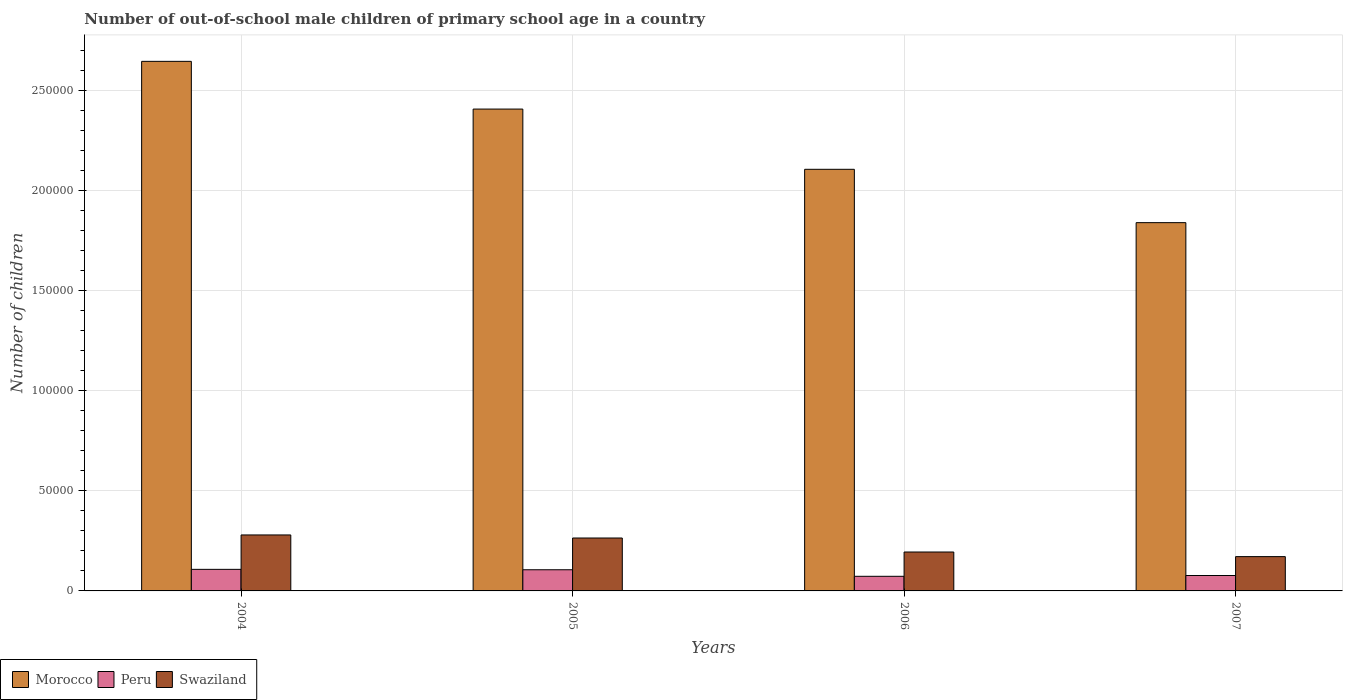How many groups of bars are there?
Give a very brief answer. 4. How many bars are there on the 3rd tick from the right?
Your answer should be very brief. 3. What is the number of out-of-school male children in Morocco in 2007?
Keep it short and to the point. 1.84e+05. Across all years, what is the maximum number of out-of-school male children in Swaziland?
Your answer should be compact. 2.79e+04. Across all years, what is the minimum number of out-of-school male children in Morocco?
Make the answer very short. 1.84e+05. In which year was the number of out-of-school male children in Peru minimum?
Your response must be concise. 2006. What is the total number of out-of-school male children in Peru in the graph?
Your response must be concise. 3.63e+04. What is the difference between the number of out-of-school male children in Swaziland in 2004 and that in 2006?
Your answer should be very brief. 8516. What is the difference between the number of out-of-school male children in Swaziland in 2007 and the number of out-of-school male children in Peru in 2006?
Provide a short and direct response. 9829. What is the average number of out-of-school male children in Swaziland per year?
Give a very brief answer. 2.27e+04. In the year 2005, what is the difference between the number of out-of-school male children in Swaziland and number of out-of-school male children in Peru?
Your answer should be very brief. 1.58e+04. In how many years, is the number of out-of-school male children in Morocco greater than 30000?
Offer a terse response. 4. What is the ratio of the number of out-of-school male children in Peru in 2004 to that in 2006?
Make the answer very short. 1.48. Is the number of out-of-school male children in Swaziland in 2004 less than that in 2007?
Your response must be concise. No. Is the difference between the number of out-of-school male children in Swaziland in 2004 and 2006 greater than the difference between the number of out-of-school male children in Peru in 2004 and 2006?
Your answer should be compact. Yes. What is the difference between the highest and the second highest number of out-of-school male children in Swaziland?
Make the answer very short. 1529. What is the difference between the highest and the lowest number of out-of-school male children in Swaziland?
Offer a terse response. 1.08e+04. Is the sum of the number of out-of-school male children in Swaziland in 2006 and 2007 greater than the maximum number of out-of-school male children in Peru across all years?
Provide a short and direct response. Yes. What does the 1st bar from the right in 2006 represents?
Provide a short and direct response. Swaziland. Is it the case that in every year, the sum of the number of out-of-school male children in Peru and number of out-of-school male children in Morocco is greater than the number of out-of-school male children in Swaziland?
Offer a very short reply. Yes. How many years are there in the graph?
Ensure brevity in your answer.  4. Are the values on the major ticks of Y-axis written in scientific E-notation?
Offer a very short reply. No. Does the graph contain any zero values?
Ensure brevity in your answer.  No. Does the graph contain grids?
Your answer should be compact. Yes. Where does the legend appear in the graph?
Your response must be concise. Bottom left. What is the title of the graph?
Offer a very short reply. Number of out-of-school male children of primary school age in a country. Does "Maldives" appear as one of the legend labels in the graph?
Provide a short and direct response. No. What is the label or title of the Y-axis?
Your answer should be compact. Number of children. What is the Number of children in Morocco in 2004?
Keep it short and to the point. 2.64e+05. What is the Number of children of Peru in 2004?
Offer a terse response. 1.08e+04. What is the Number of children of Swaziland in 2004?
Your answer should be compact. 2.79e+04. What is the Number of children in Morocco in 2005?
Make the answer very short. 2.41e+05. What is the Number of children of Peru in 2005?
Ensure brevity in your answer.  1.06e+04. What is the Number of children of Swaziland in 2005?
Your response must be concise. 2.64e+04. What is the Number of children of Morocco in 2006?
Provide a succinct answer. 2.10e+05. What is the Number of children in Peru in 2006?
Make the answer very short. 7293. What is the Number of children in Swaziland in 2006?
Your response must be concise. 1.94e+04. What is the Number of children of Morocco in 2007?
Your answer should be compact. 1.84e+05. What is the Number of children in Peru in 2007?
Give a very brief answer. 7691. What is the Number of children in Swaziland in 2007?
Offer a very short reply. 1.71e+04. Across all years, what is the maximum Number of children in Morocco?
Give a very brief answer. 2.64e+05. Across all years, what is the maximum Number of children in Peru?
Give a very brief answer. 1.08e+04. Across all years, what is the maximum Number of children in Swaziland?
Your answer should be compact. 2.79e+04. Across all years, what is the minimum Number of children in Morocco?
Offer a very short reply. 1.84e+05. Across all years, what is the minimum Number of children in Peru?
Offer a very short reply. 7293. Across all years, what is the minimum Number of children in Swaziland?
Provide a succinct answer. 1.71e+04. What is the total Number of children of Morocco in the graph?
Provide a succinct answer. 8.99e+05. What is the total Number of children in Peru in the graph?
Keep it short and to the point. 3.63e+04. What is the total Number of children in Swaziland in the graph?
Provide a succinct answer. 9.09e+04. What is the difference between the Number of children of Morocco in 2004 and that in 2005?
Keep it short and to the point. 2.38e+04. What is the difference between the Number of children in Peru in 2004 and that in 2005?
Offer a very short reply. 203. What is the difference between the Number of children of Swaziland in 2004 and that in 2005?
Keep it short and to the point. 1529. What is the difference between the Number of children in Morocco in 2004 and that in 2006?
Offer a very short reply. 5.39e+04. What is the difference between the Number of children in Peru in 2004 and that in 2006?
Ensure brevity in your answer.  3475. What is the difference between the Number of children of Swaziland in 2004 and that in 2006?
Offer a terse response. 8516. What is the difference between the Number of children of Morocco in 2004 and that in 2007?
Your answer should be very brief. 8.05e+04. What is the difference between the Number of children of Peru in 2004 and that in 2007?
Make the answer very short. 3077. What is the difference between the Number of children in Swaziland in 2004 and that in 2007?
Make the answer very short. 1.08e+04. What is the difference between the Number of children in Morocco in 2005 and that in 2006?
Keep it short and to the point. 3.01e+04. What is the difference between the Number of children in Peru in 2005 and that in 2006?
Offer a terse response. 3272. What is the difference between the Number of children in Swaziland in 2005 and that in 2006?
Provide a succinct answer. 6987. What is the difference between the Number of children in Morocco in 2005 and that in 2007?
Your answer should be compact. 5.67e+04. What is the difference between the Number of children in Peru in 2005 and that in 2007?
Your response must be concise. 2874. What is the difference between the Number of children in Swaziland in 2005 and that in 2007?
Your answer should be very brief. 9286. What is the difference between the Number of children in Morocco in 2006 and that in 2007?
Your answer should be very brief. 2.66e+04. What is the difference between the Number of children in Peru in 2006 and that in 2007?
Offer a terse response. -398. What is the difference between the Number of children in Swaziland in 2006 and that in 2007?
Offer a terse response. 2299. What is the difference between the Number of children of Morocco in 2004 and the Number of children of Peru in 2005?
Keep it short and to the point. 2.54e+05. What is the difference between the Number of children of Morocco in 2004 and the Number of children of Swaziland in 2005?
Provide a short and direct response. 2.38e+05. What is the difference between the Number of children in Peru in 2004 and the Number of children in Swaziland in 2005?
Provide a short and direct response. -1.56e+04. What is the difference between the Number of children of Morocco in 2004 and the Number of children of Peru in 2006?
Keep it short and to the point. 2.57e+05. What is the difference between the Number of children in Morocco in 2004 and the Number of children in Swaziland in 2006?
Your answer should be very brief. 2.45e+05. What is the difference between the Number of children in Peru in 2004 and the Number of children in Swaziland in 2006?
Make the answer very short. -8653. What is the difference between the Number of children of Morocco in 2004 and the Number of children of Peru in 2007?
Offer a very short reply. 2.57e+05. What is the difference between the Number of children in Morocco in 2004 and the Number of children in Swaziland in 2007?
Keep it short and to the point. 2.47e+05. What is the difference between the Number of children in Peru in 2004 and the Number of children in Swaziland in 2007?
Your response must be concise. -6354. What is the difference between the Number of children in Morocco in 2005 and the Number of children in Peru in 2006?
Provide a succinct answer. 2.33e+05. What is the difference between the Number of children of Morocco in 2005 and the Number of children of Swaziland in 2006?
Ensure brevity in your answer.  2.21e+05. What is the difference between the Number of children of Peru in 2005 and the Number of children of Swaziland in 2006?
Keep it short and to the point. -8856. What is the difference between the Number of children in Morocco in 2005 and the Number of children in Peru in 2007?
Your response must be concise. 2.33e+05. What is the difference between the Number of children of Morocco in 2005 and the Number of children of Swaziland in 2007?
Offer a terse response. 2.23e+05. What is the difference between the Number of children in Peru in 2005 and the Number of children in Swaziland in 2007?
Provide a short and direct response. -6557. What is the difference between the Number of children of Morocco in 2006 and the Number of children of Peru in 2007?
Provide a succinct answer. 2.03e+05. What is the difference between the Number of children in Morocco in 2006 and the Number of children in Swaziland in 2007?
Offer a terse response. 1.93e+05. What is the difference between the Number of children in Peru in 2006 and the Number of children in Swaziland in 2007?
Offer a very short reply. -9829. What is the average Number of children in Morocco per year?
Offer a very short reply. 2.25e+05. What is the average Number of children in Peru per year?
Keep it short and to the point. 9079.25. What is the average Number of children in Swaziland per year?
Your response must be concise. 2.27e+04. In the year 2004, what is the difference between the Number of children in Morocco and Number of children in Peru?
Ensure brevity in your answer.  2.54e+05. In the year 2004, what is the difference between the Number of children in Morocco and Number of children in Swaziland?
Your answer should be very brief. 2.36e+05. In the year 2004, what is the difference between the Number of children of Peru and Number of children of Swaziland?
Make the answer very short. -1.72e+04. In the year 2005, what is the difference between the Number of children of Morocco and Number of children of Peru?
Offer a terse response. 2.30e+05. In the year 2005, what is the difference between the Number of children of Morocco and Number of children of Swaziland?
Offer a terse response. 2.14e+05. In the year 2005, what is the difference between the Number of children of Peru and Number of children of Swaziland?
Offer a very short reply. -1.58e+04. In the year 2006, what is the difference between the Number of children of Morocco and Number of children of Peru?
Keep it short and to the point. 2.03e+05. In the year 2006, what is the difference between the Number of children in Morocco and Number of children in Swaziland?
Keep it short and to the point. 1.91e+05. In the year 2006, what is the difference between the Number of children of Peru and Number of children of Swaziland?
Your answer should be compact. -1.21e+04. In the year 2007, what is the difference between the Number of children in Morocco and Number of children in Peru?
Provide a short and direct response. 1.76e+05. In the year 2007, what is the difference between the Number of children in Morocco and Number of children in Swaziland?
Keep it short and to the point. 1.67e+05. In the year 2007, what is the difference between the Number of children in Peru and Number of children in Swaziland?
Give a very brief answer. -9431. What is the ratio of the Number of children of Morocco in 2004 to that in 2005?
Your answer should be very brief. 1.1. What is the ratio of the Number of children in Peru in 2004 to that in 2005?
Offer a very short reply. 1.02. What is the ratio of the Number of children in Swaziland in 2004 to that in 2005?
Your answer should be compact. 1.06. What is the ratio of the Number of children in Morocco in 2004 to that in 2006?
Provide a short and direct response. 1.26. What is the ratio of the Number of children of Peru in 2004 to that in 2006?
Your response must be concise. 1.48. What is the ratio of the Number of children of Swaziland in 2004 to that in 2006?
Your answer should be very brief. 1.44. What is the ratio of the Number of children in Morocco in 2004 to that in 2007?
Provide a succinct answer. 1.44. What is the ratio of the Number of children in Peru in 2004 to that in 2007?
Your answer should be very brief. 1.4. What is the ratio of the Number of children in Swaziland in 2004 to that in 2007?
Your response must be concise. 1.63. What is the ratio of the Number of children of Morocco in 2005 to that in 2006?
Offer a terse response. 1.14. What is the ratio of the Number of children in Peru in 2005 to that in 2006?
Offer a very short reply. 1.45. What is the ratio of the Number of children of Swaziland in 2005 to that in 2006?
Offer a terse response. 1.36. What is the ratio of the Number of children in Morocco in 2005 to that in 2007?
Make the answer very short. 1.31. What is the ratio of the Number of children of Peru in 2005 to that in 2007?
Your response must be concise. 1.37. What is the ratio of the Number of children of Swaziland in 2005 to that in 2007?
Your answer should be very brief. 1.54. What is the ratio of the Number of children in Morocco in 2006 to that in 2007?
Provide a short and direct response. 1.14. What is the ratio of the Number of children in Peru in 2006 to that in 2007?
Make the answer very short. 0.95. What is the ratio of the Number of children of Swaziland in 2006 to that in 2007?
Your answer should be very brief. 1.13. What is the difference between the highest and the second highest Number of children of Morocco?
Your answer should be compact. 2.38e+04. What is the difference between the highest and the second highest Number of children in Peru?
Give a very brief answer. 203. What is the difference between the highest and the second highest Number of children of Swaziland?
Your response must be concise. 1529. What is the difference between the highest and the lowest Number of children of Morocco?
Give a very brief answer. 8.05e+04. What is the difference between the highest and the lowest Number of children of Peru?
Provide a succinct answer. 3475. What is the difference between the highest and the lowest Number of children of Swaziland?
Make the answer very short. 1.08e+04. 